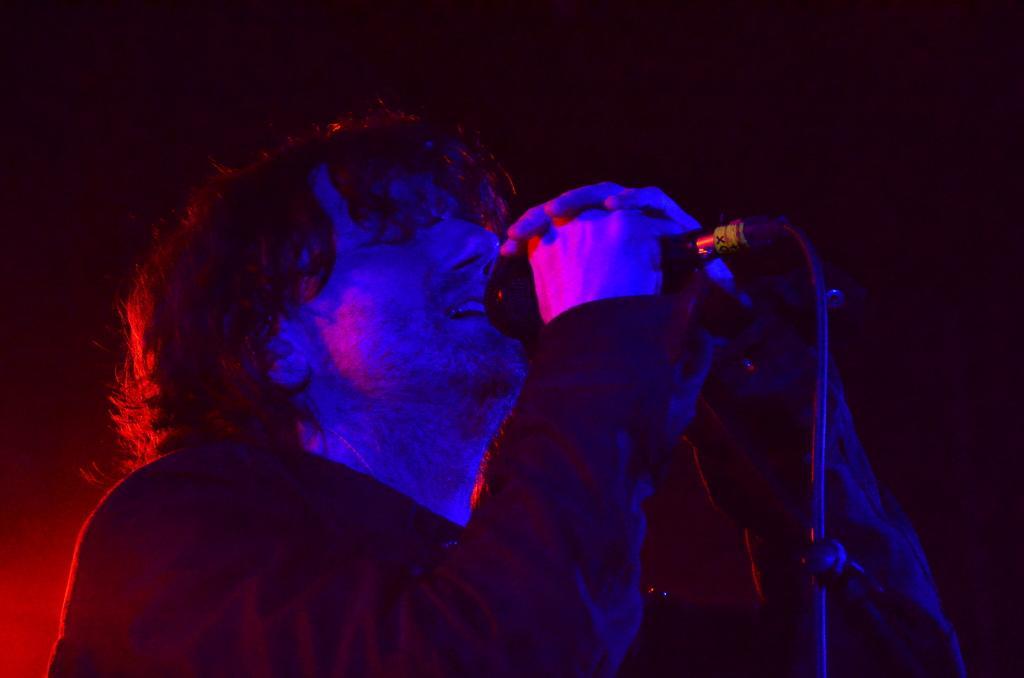Can you describe this image briefly? In this picture we can see a man holding a mic with his hands and in the background it is dark. 